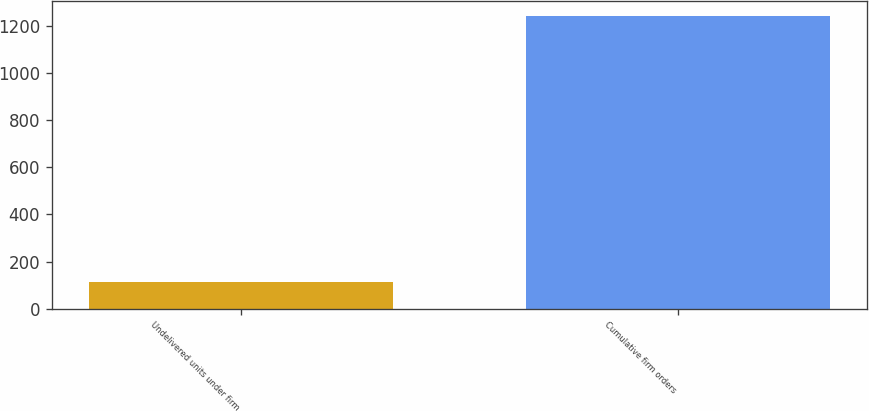Convert chart. <chart><loc_0><loc_0><loc_500><loc_500><bar_chart><fcel>Undelivered units under firm<fcel>Cumulative firm orders<nl><fcel>111<fcel>1244<nl></chart> 